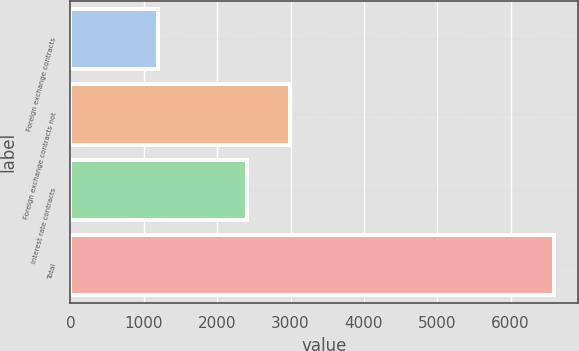Convert chart. <chart><loc_0><loc_0><loc_500><loc_500><bar_chart><fcel>Foreign exchange contracts<fcel>Foreign exchange contracts not<fcel>Interest rate contracts<fcel>Total<nl><fcel>1200<fcel>2993<fcel>2400<fcel>6593<nl></chart> 